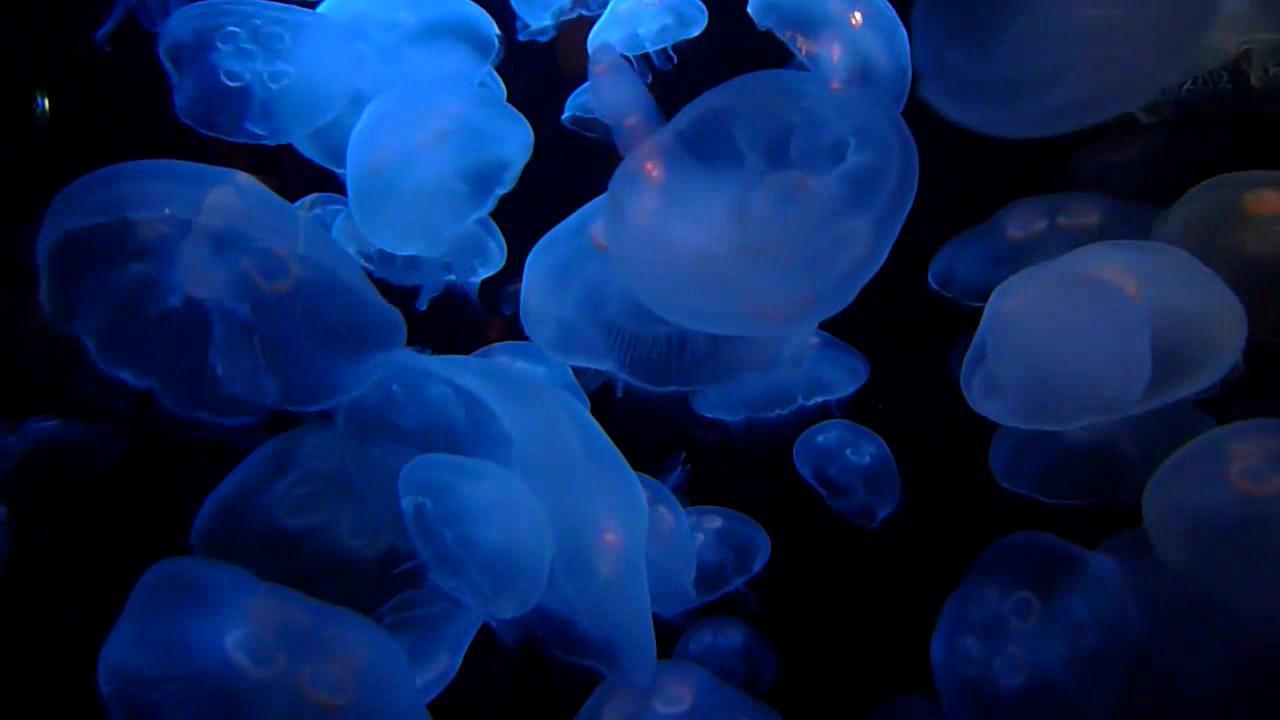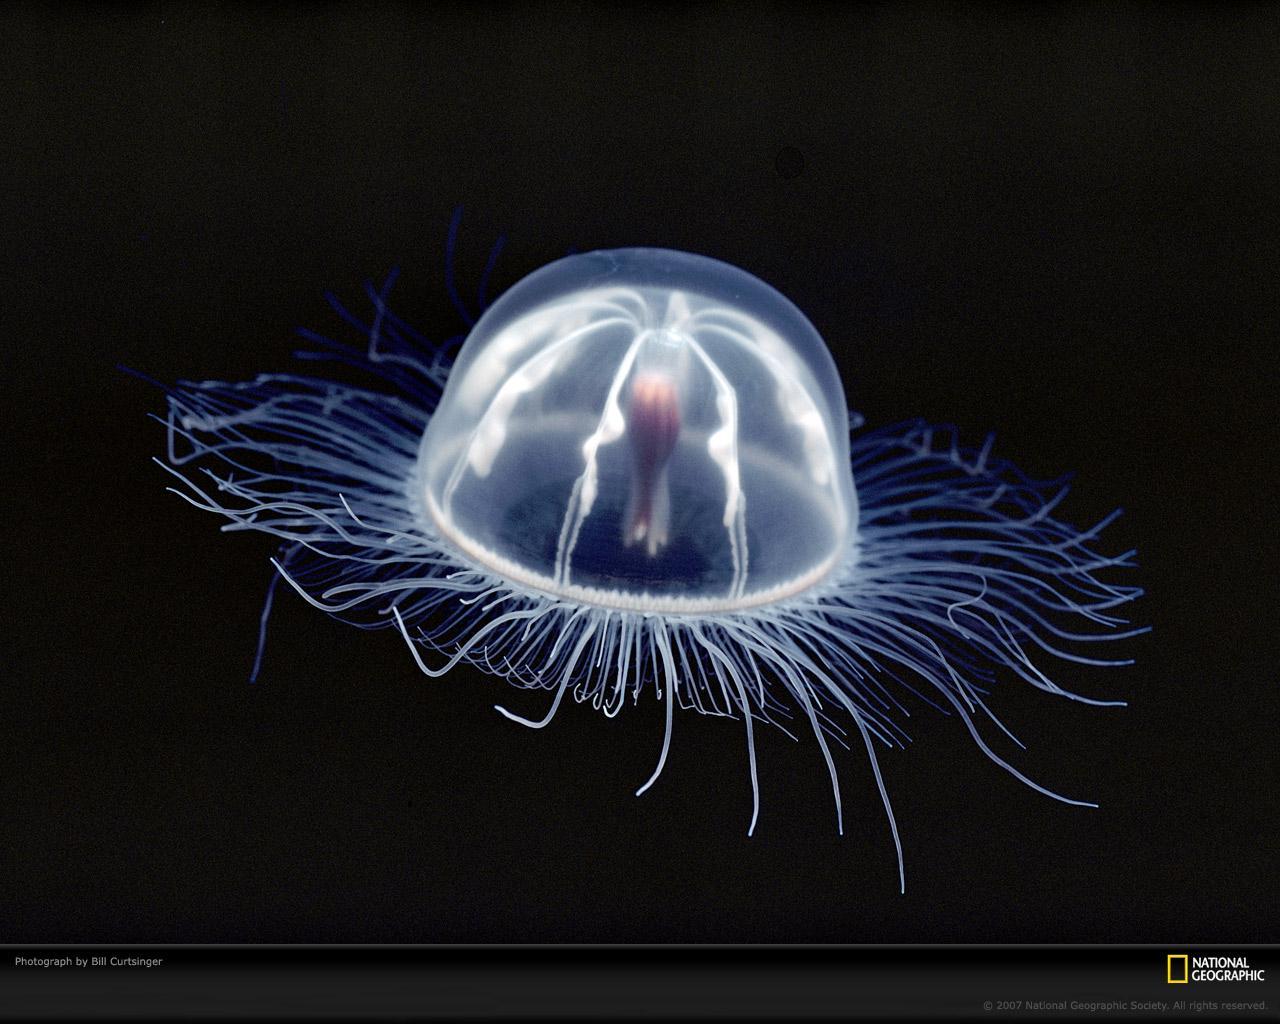The first image is the image on the left, the second image is the image on the right. Given the left and right images, does the statement "One image features a translucent blue jellyfish moving diagonally to the right, with tentacles trailing behind it." hold true? Answer yes or no. No. The first image is the image on the left, the second image is the image on the right. Evaluate the accuracy of this statement regarding the images: "There are less than 9 jellyfish.". Is it true? Answer yes or no. No. 